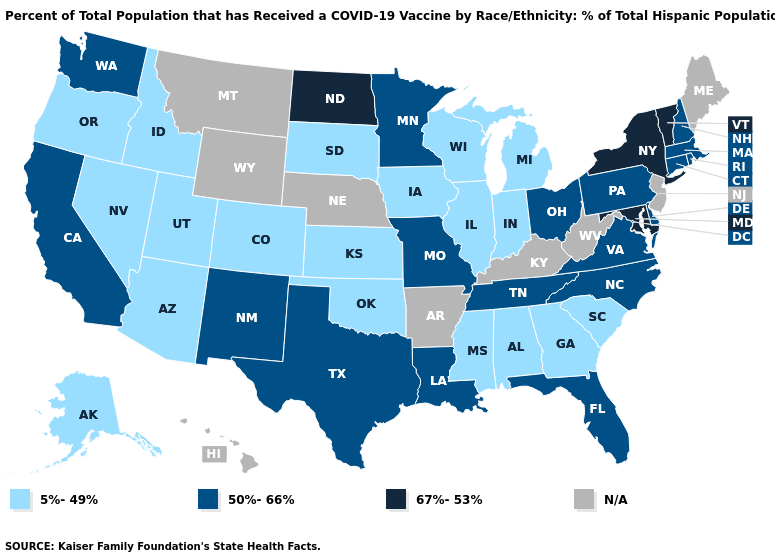Among the states that border Pennsylvania , does Ohio have the highest value?
Give a very brief answer. No. What is the lowest value in the USA?
Short answer required. 5%-49%. What is the value of Michigan?
Be succinct. 5%-49%. What is the value of Colorado?
Quick response, please. 5%-49%. Does Delaware have the lowest value in the South?
Answer briefly. No. Name the states that have a value in the range 5%-49%?
Short answer required. Alabama, Alaska, Arizona, Colorado, Georgia, Idaho, Illinois, Indiana, Iowa, Kansas, Michigan, Mississippi, Nevada, Oklahoma, Oregon, South Carolina, South Dakota, Utah, Wisconsin. What is the value of Pennsylvania?
Give a very brief answer. 50%-66%. Among the states that border North Carolina , does Georgia have the highest value?
Write a very short answer. No. What is the lowest value in states that border New York?
Write a very short answer. 50%-66%. Name the states that have a value in the range 67%-53%?
Keep it brief. Maryland, New York, North Dakota, Vermont. Name the states that have a value in the range 67%-53%?
Keep it brief. Maryland, New York, North Dakota, Vermont. Does the first symbol in the legend represent the smallest category?
Answer briefly. Yes. Name the states that have a value in the range 67%-53%?
Answer briefly. Maryland, New York, North Dakota, Vermont. What is the highest value in the West ?
Quick response, please. 50%-66%. 